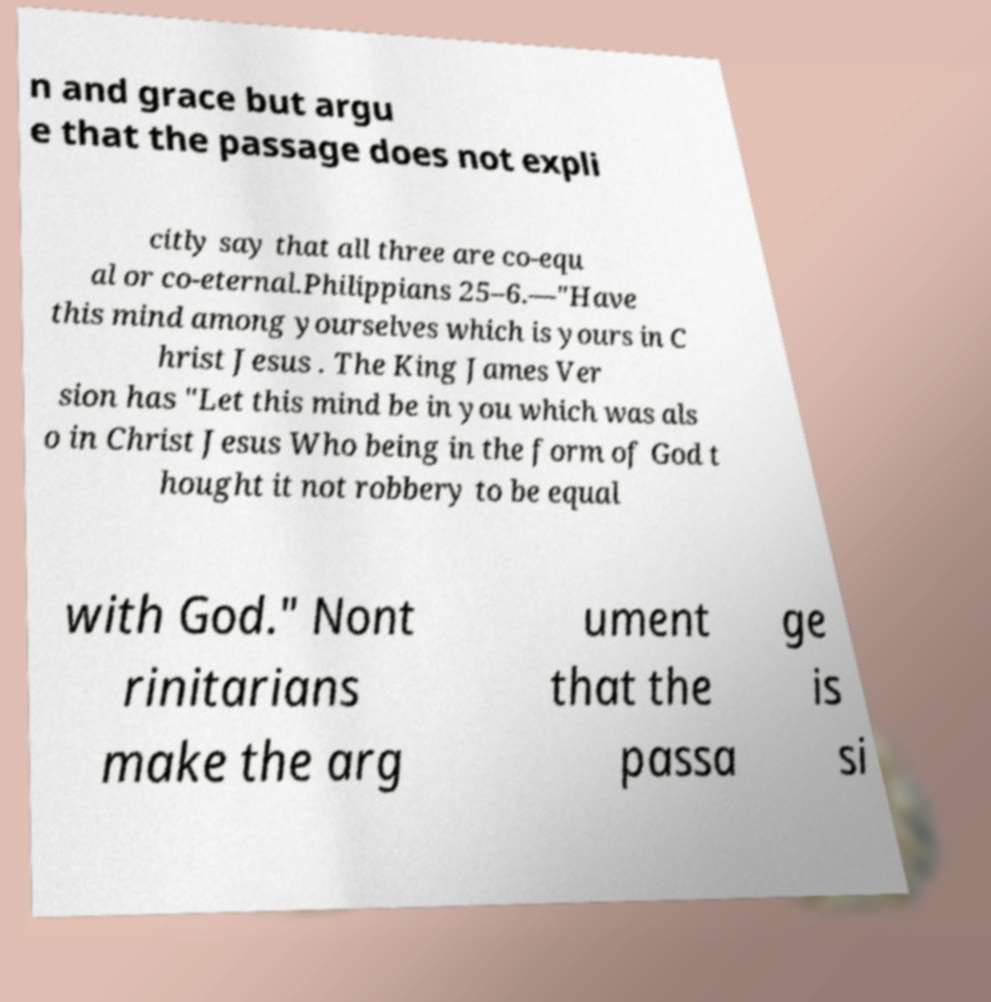Can you accurately transcribe the text from the provided image for me? n and grace but argu e that the passage does not expli citly say that all three are co-equ al or co-eternal.Philippians 25–6.—"Have this mind among yourselves which is yours in C hrist Jesus . The King James Ver sion has "Let this mind be in you which was als o in Christ Jesus Who being in the form of God t hought it not robbery to be equal with God." Nont rinitarians make the arg ument that the passa ge is si 